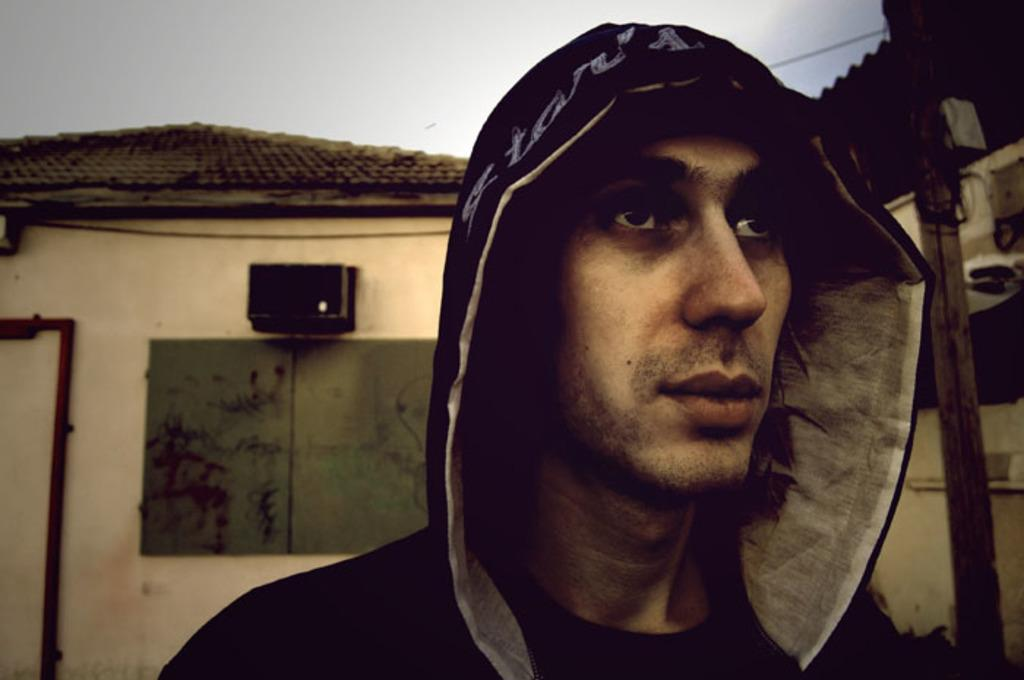Who or what is in the image? There is a person in the image. What is located behind the person? There is a house behind the person. What type of lace can be seen on the person's clothing in the image? There is no lace visible on the person's clothing in the image. What shape is the house behind the person? The shape of the house cannot be determined from the image alone, as only a portion of the house is visible. 